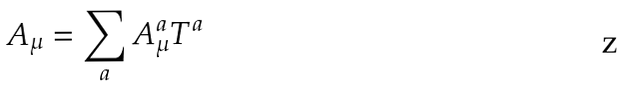Convert formula to latex. <formula><loc_0><loc_0><loc_500><loc_500>A _ { \mu } = \sum _ { a } A _ { \mu } ^ { a } T ^ { a }</formula> 